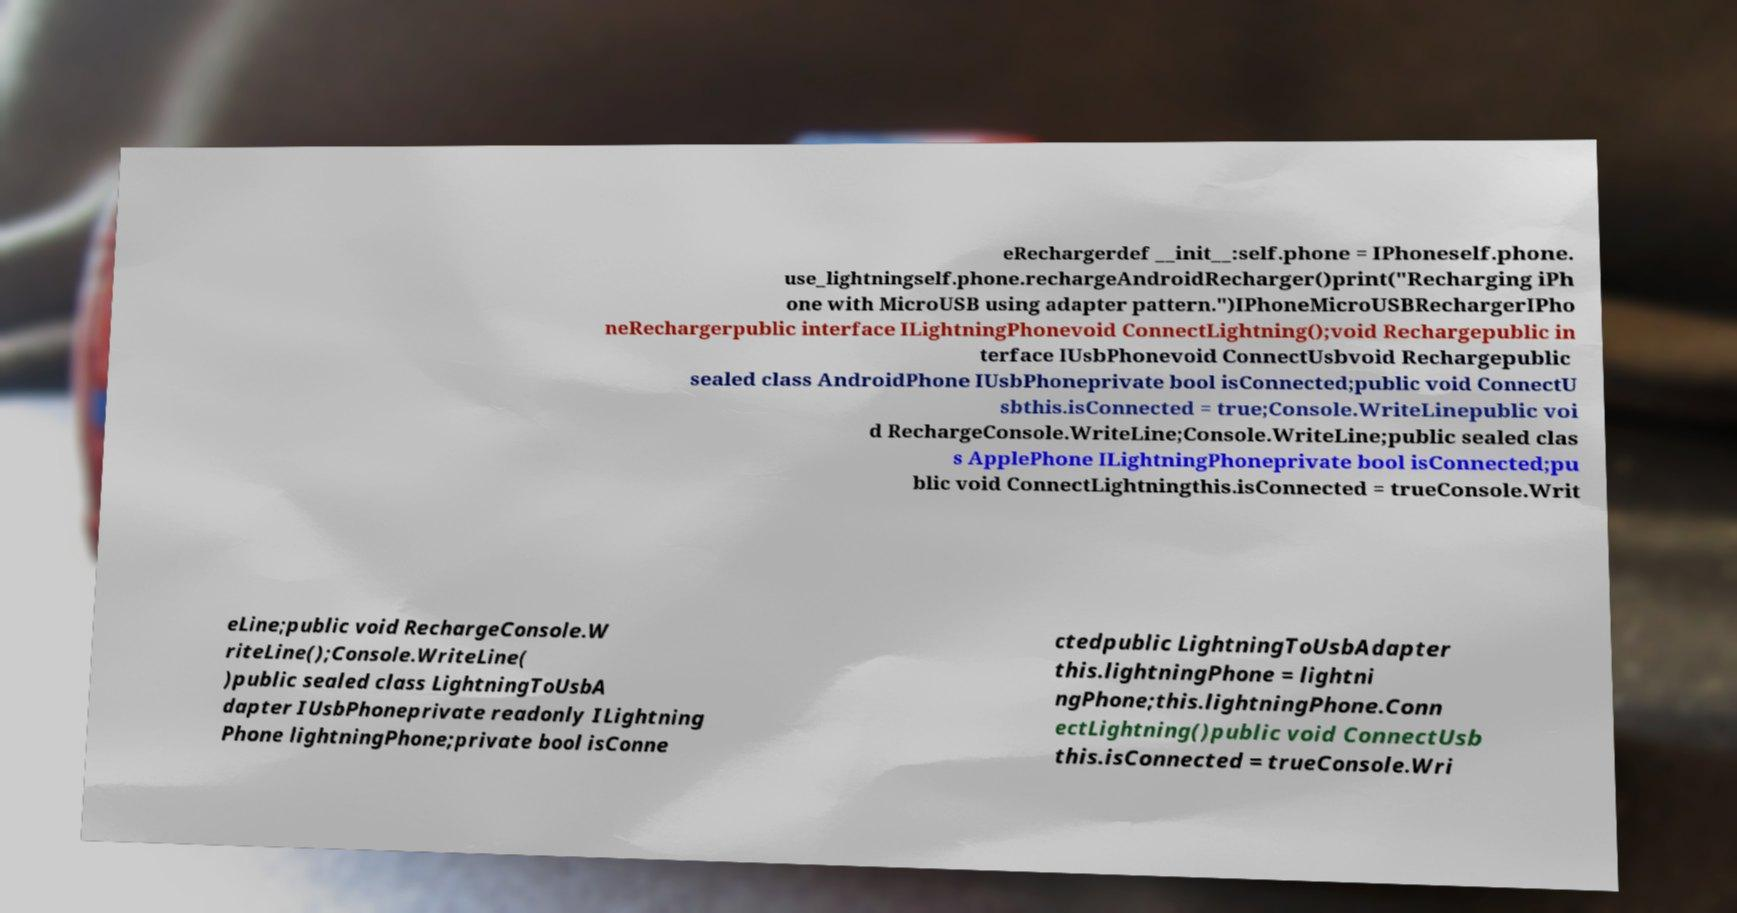There's text embedded in this image that I need extracted. Can you transcribe it verbatim? eRechargerdef __init__:self.phone = IPhoneself.phone. use_lightningself.phone.rechargeAndroidRecharger()print("Recharging iPh one with MicroUSB using adapter pattern.")IPhoneMicroUSBRechargerIPho neRechargerpublic interface ILightningPhonevoid ConnectLightning();void Rechargepublic in terface IUsbPhonevoid ConnectUsbvoid Rechargepublic sealed class AndroidPhone IUsbPhoneprivate bool isConnected;public void ConnectU sbthis.isConnected = true;Console.WriteLinepublic voi d RechargeConsole.WriteLine;Console.WriteLine;public sealed clas s ApplePhone ILightningPhoneprivate bool isConnected;pu blic void ConnectLightningthis.isConnected = trueConsole.Writ eLine;public void RechargeConsole.W riteLine();Console.WriteLine( )public sealed class LightningToUsbA dapter IUsbPhoneprivate readonly ILightning Phone lightningPhone;private bool isConne ctedpublic LightningToUsbAdapter this.lightningPhone = lightni ngPhone;this.lightningPhone.Conn ectLightning()public void ConnectUsb this.isConnected = trueConsole.Wri 